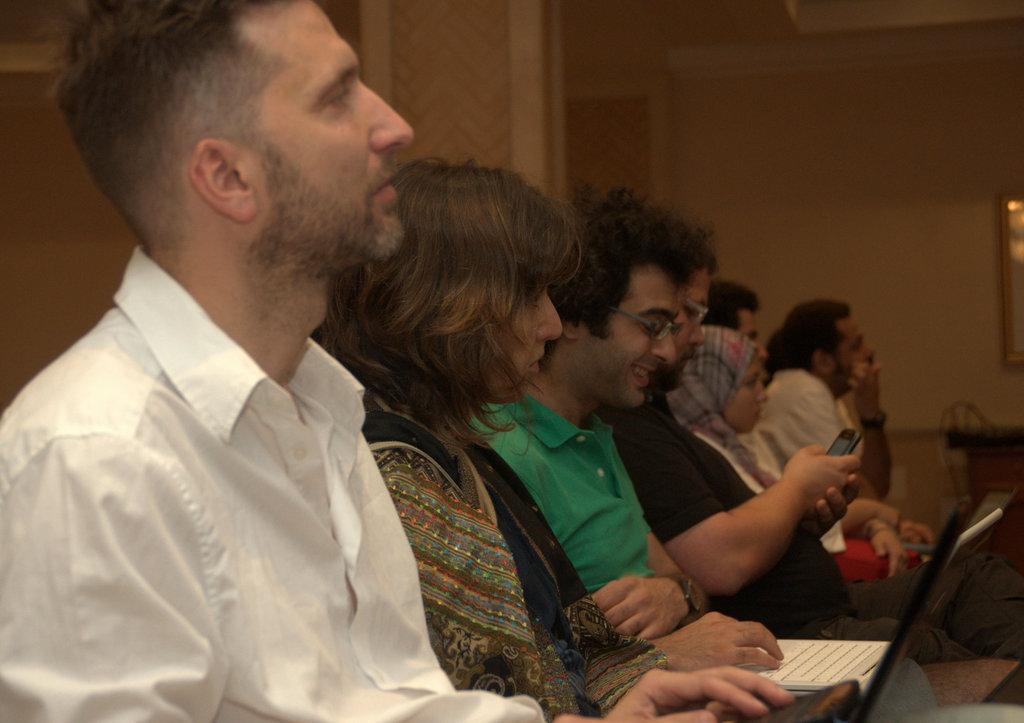How would you summarize this image in a sentence or two? In this image we can see group of people sitting on the chairs holding laptop and mobile phone. In the background we can see photo frame, pillar and wall. 